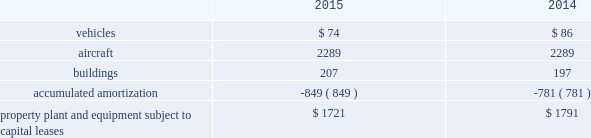United parcel service , inc .
And subsidiaries notes to consolidated financial statements capital lease obligations we have certain property , plant and equipment subject to capital leases .
Some of the obligations associated with these capital leases have been legally defeased .
The recorded value of our property , plant and equipment subject to capital leases is as follows as of december 31 ( in millions ) : .
These capital lease obligations have principal payments due at various dates from 2016 through 3005 .
Facility notes and bonds we have entered into agreements with certain municipalities to finance the construction of , or improvements to , facilities that support our u.s .
Domestic package and supply chain & freight operations in the united states .
These facilities are located around airport properties in louisville , kentucky ; dallas , texas ; and philadelphia , pennsylvania .
Under these arrangements , we enter into a lease or loan agreement that covers the debt service obligations on the bonds issued by the municipalities , as follows : 2022 bonds with a principal balance of $ 149 million issued by the louisville regional airport authority associated with our worldport facility in louisville , kentucky .
The bonds , which are due in january 2029 , bear interest at a variable rate , and the average interest rates for 2015 and 2014 were 0.03% ( 0.03 % ) and 0.05% ( 0.05 % ) , respectively .
2022 bonds with a principal balance of $ 42 million and due in november 2036 issued by the louisville regional airport authority associated with our air freight facility in louisville , kentucky .
The bonds bear interest at a variable rate , and the average interest rates for 2015 and 2014 were 0.02% ( 0.02 % ) and 0.05% ( 0.05 % ) , respectively .
2022 bonds with a principal balance of $ 29 million issued by the dallas / fort worth international airport facility improvement corporation associated with our dallas , texas airport facilities .
The bonds are due in may 2032 and bear interest at a variable rate , however the variable cash flows on the obligation have been swapped to a fixed 5.11% ( 5.11 % ) .
2022 bonds with a principal balance of $ 100 million issued by the delaware county , pennsylvania industrial development authority associated with our philadelphia , pennsylvania airport facilities .
The bonds , which were due in december 2015 , had a variable interest rate , and the average interest rates for 2015 and 2014 were 0.02% ( 0.02 % ) and 0.04% ( 0.04 % ) , respectively .
As of december 2015 , these $ 100 million bonds were repaid in full .
2022 in september 2015 , we entered into an agreement with the delaware county , pennsylvania industrial development authority , associated with our philadelphia , pennsylvania airport facilities , for bonds issued with a principal balance of $ 100 million .
These bonds , which are due september 2045 , bear interest at a variable rate .
The average interest rate for 2015 was 0.00% ( 0.00 % ) .
Pound sterling notes the pound sterling notes consist of two separate tranches , as follows : 2022 notes with a principal amount of a366 million accrue interest at a 5.50% ( 5.50 % ) fixed rate , and are due in february 2031 .
These notes are not callable .
2022 notes with a principal amount of a3455 million accrue interest at a 5.125% ( 5.125 % ) fixed rate , and are due in february 2050 .
These notes are callable at our option at a redemption price equal to the greater of 100% ( 100 % ) of the principal amount and accrued interest , or the sum of the present values of the remaining scheduled payout of principal and interest thereon discounted to the date of redemption at a benchmark u.k .
Government bond yield plus 15 basis points and accrued interest. .
What was the change in millions of vehicles from 2014 to 2015? 
Computations: (74 - 86)
Answer: -12.0. 